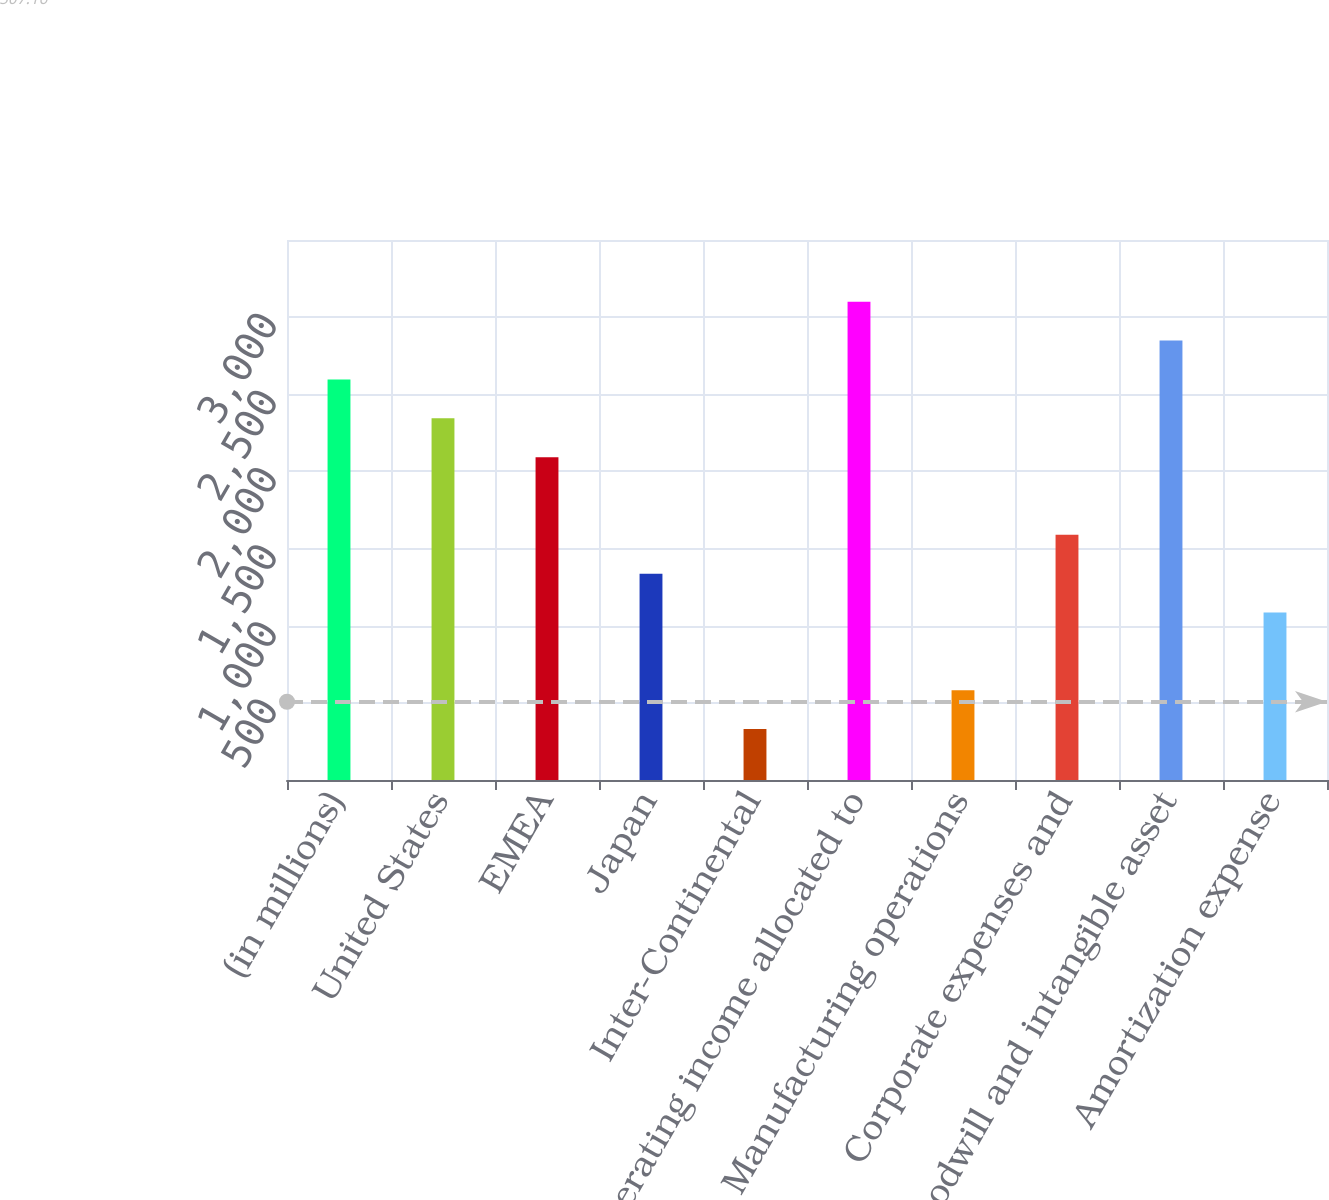Convert chart. <chart><loc_0><loc_0><loc_500><loc_500><bar_chart><fcel>(in millions)<fcel>United States<fcel>EMEA<fcel>Japan<fcel>Inter-Continental<fcel>Operating income allocated to<fcel>Manufacturing operations<fcel>Corporate expenses and<fcel>Goodwill and intangible asset<fcel>Amortization expense<nl><fcel>2596.2<fcel>2344.4<fcel>2092.6<fcel>1337.2<fcel>330<fcel>3099.8<fcel>581.8<fcel>1589<fcel>2848<fcel>1085.4<nl></chart> 